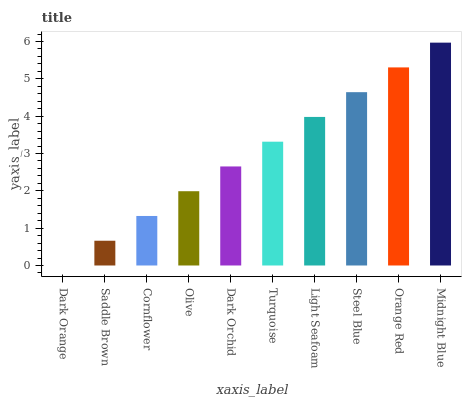Is Dark Orange the minimum?
Answer yes or no. Yes. Is Midnight Blue the maximum?
Answer yes or no. Yes. Is Saddle Brown the minimum?
Answer yes or no. No. Is Saddle Brown the maximum?
Answer yes or no. No. Is Saddle Brown greater than Dark Orange?
Answer yes or no. Yes. Is Dark Orange less than Saddle Brown?
Answer yes or no. Yes. Is Dark Orange greater than Saddle Brown?
Answer yes or no. No. Is Saddle Brown less than Dark Orange?
Answer yes or no. No. Is Turquoise the high median?
Answer yes or no. Yes. Is Dark Orchid the low median?
Answer yes or no. Yes. Is Dark Orange the high median?
Answer yes or no. No. Is Orange Red the low median?
Answer yes or no. No. 